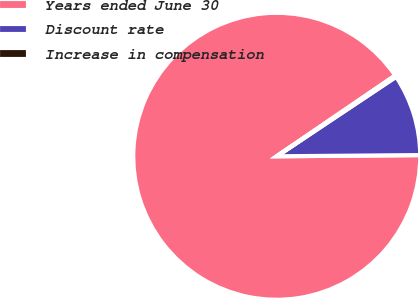Convert chart. <chart><loc_0><loc_0><loc_500><loc_500><pie_chart><fcel>Years ended June 30<fcel>Discount rate<fcel>Increase in compensation<nl><fcel>90.6%<fcel>9.22%<fcel>0.18%<nl></chart> 